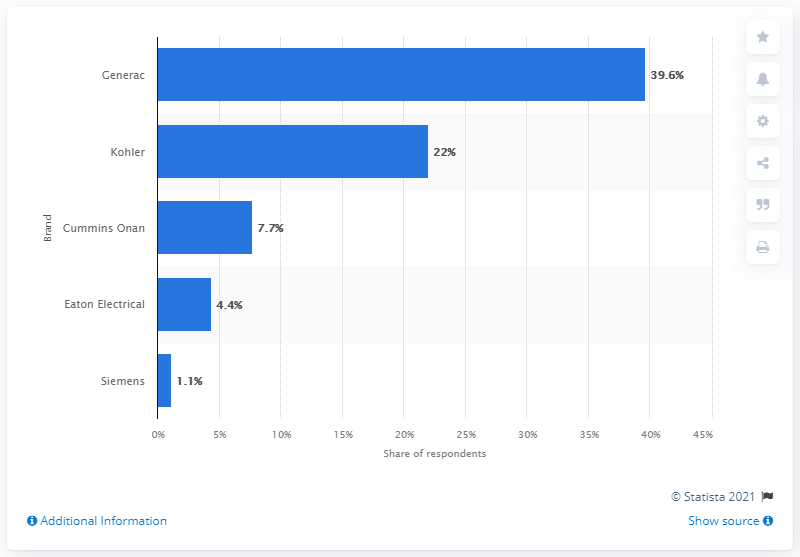Draw attention to some important aspects in this diagram. According to the survey results, the brand of stationary generators that was used most by respondents was Generac, with 39.6% of respondents reporting that they used this brand the most. 